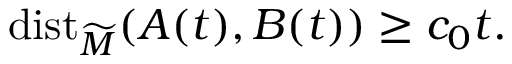Convert formula to latex. <formula><loc_0><loc_0><loc_500><loc_500>d i s t _ { \widetilde { M } } ( A ( t ) , B ( t ) ) \geq c _ { 0 } t .</formula> 